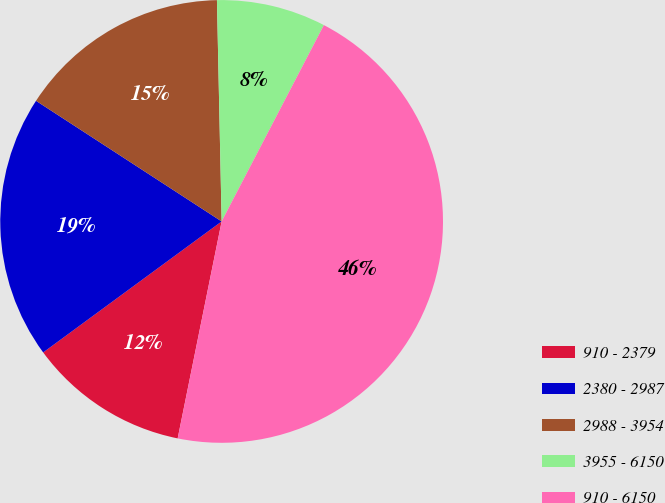<chart> <loc_0><loc_0><loc_500><loc_500><pie_chart><fcel>910 - 2379<fcel>2380 - 2987<fcel>2988 - 3954<fcel>3955 - 6150<fcel>910 - 6150<nl><fcel>11.74%<fcel>19.25%<fcel>15.49%<fcel>7.98%<fcel>45.54%<nl></chart> 